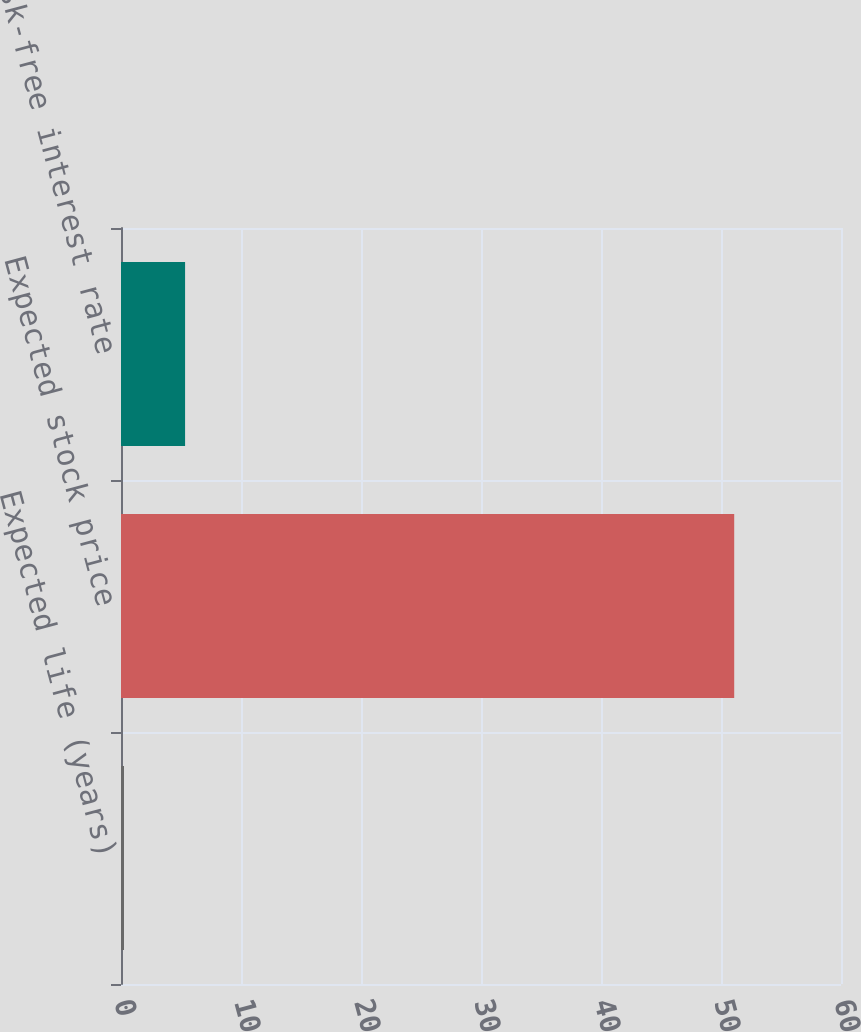<chart> <loc_0><loc_0><loc_500><loc_500><bar_chart><fcel>Expected life (years)<fcel>Expected stock price<fcel>Risk-free interest rate<nl><fcel>0.25<fcel>51.1<fcel>5.34<nl></chart> 